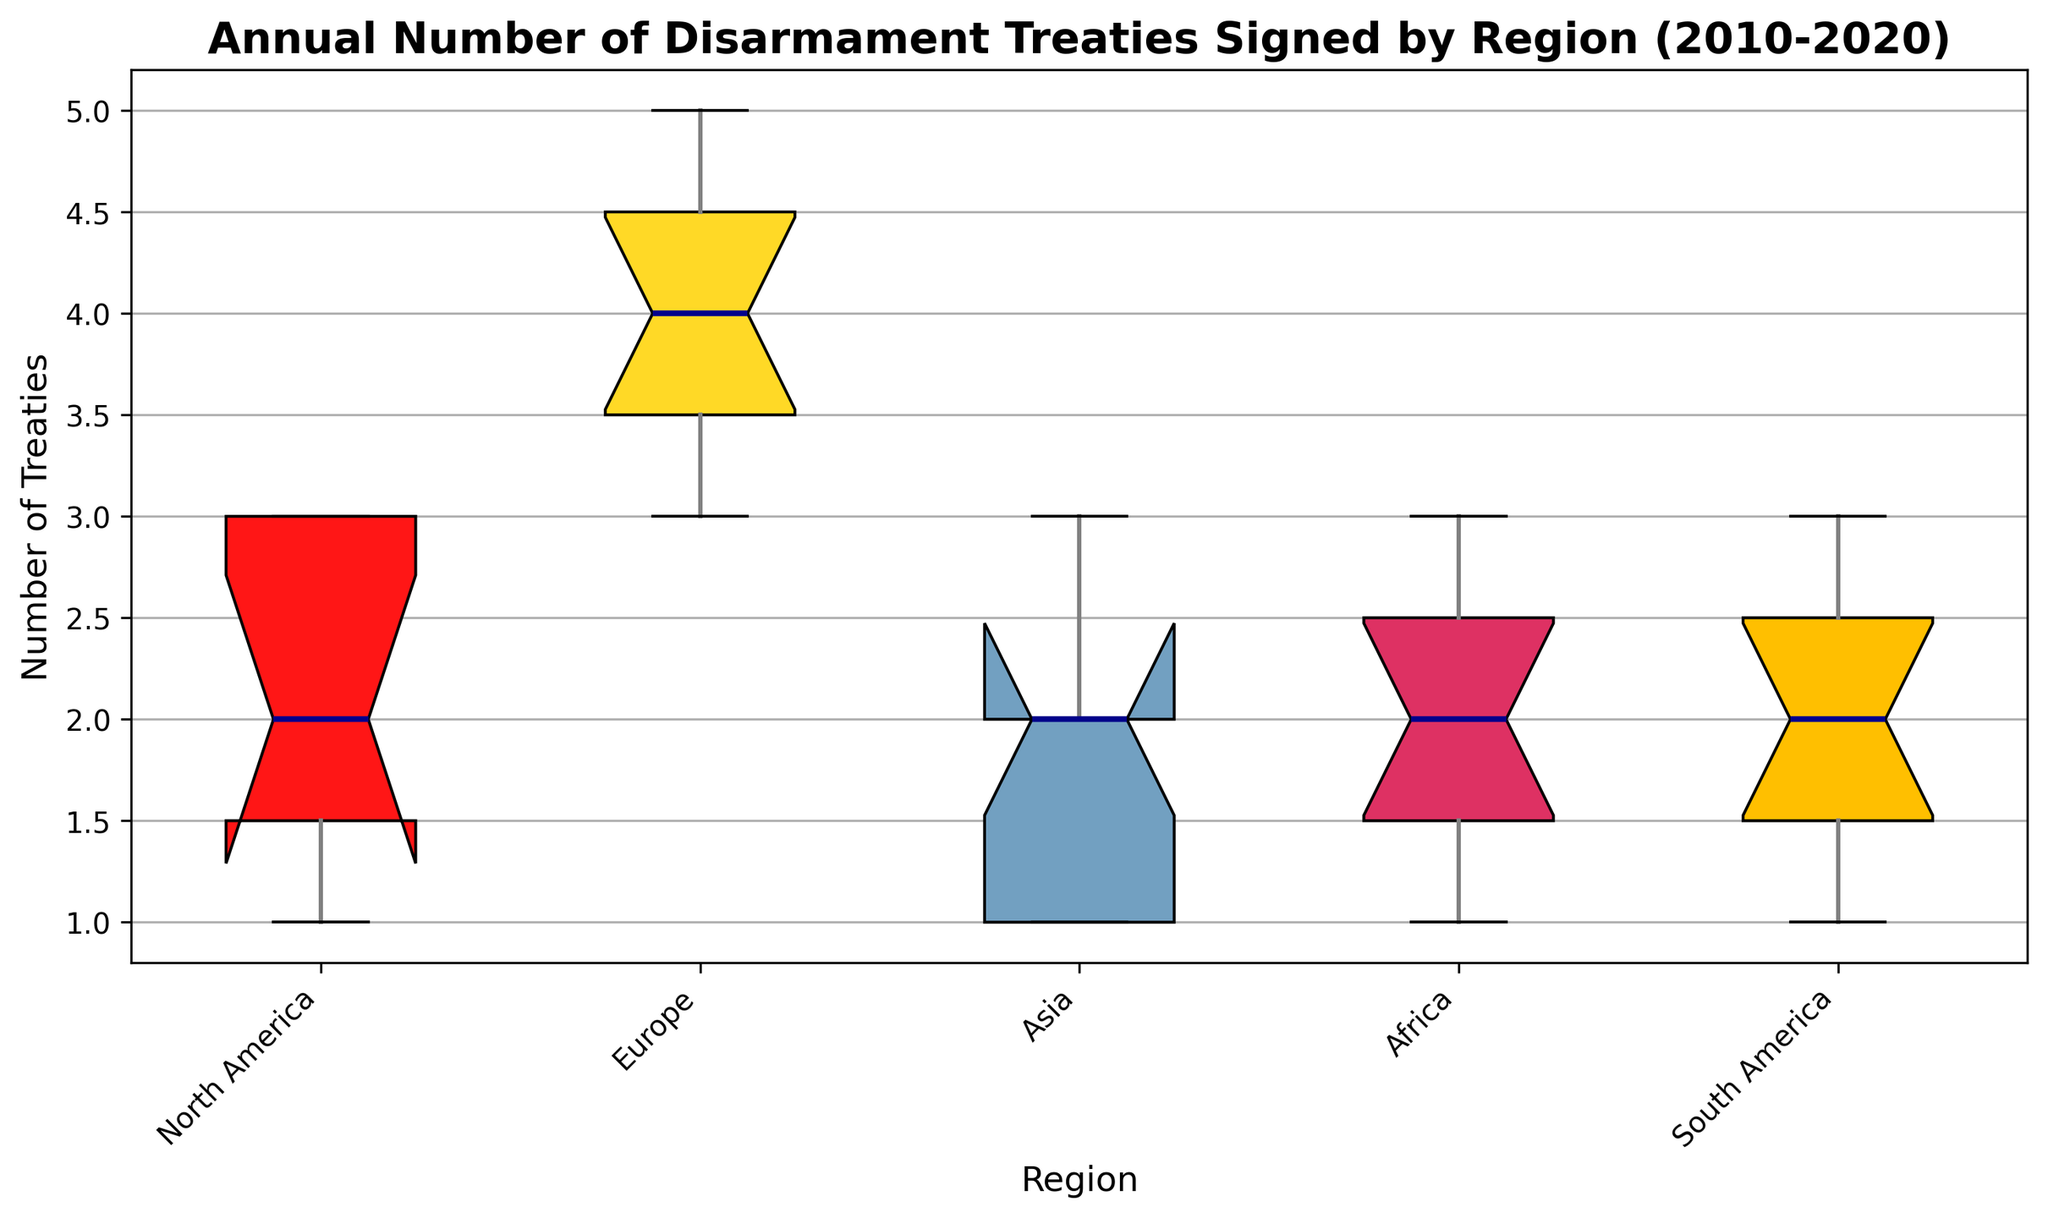Which region has the highest median number of treaties signed annually? Visually inspect the median lines within each box: North America's box plot has a median around 2, Europe around 4, Asia around 2, Africa around 2, and South America around 2. The highest median is Europe.
Answer: Europe Which region shows the most variability in the number of treaties signed annually? To determine this, look for the widest interquartile range (IQR) or the longest whiskers. Europe shows the widest IQR and longest whiskers, indicating the most variability.
Answer: Europe Are there any regions where the number of treaties signed annually remained constant across the years? If the box plot for a region is very narrow with no outliers, it suggests low variability and possibly a constant number. All regions show some variability; hence, none remained constant.
Answer: No Between North America and Asia, which region has a higher maximum number of treaties signed in a year? Compare the top whisker endpoints of North America and Asia. North America's top whisker ends at 3, and Asia's top whisker also ends at 3. Both have the same maximum number.
Answer: Equal Is there any region that has outliers? Outliers are usually depicted as individual points outside the whiskers. None of the box plots has individual points outside the whiskers, indicating no outliers.
Answer: No How does the median number of treaties signed in South America compare to that in North America? Visually compare the median lines of South America and North America. Both have a median around 2, indicating they are equal.
Answer: Equal Which region shows the least variability in the number of treaties signed annually? Look for the narrowest IQR or shortest whiskers. North America has the narrowest IQR and shortest whiskers, indicating the least variability.
Answer: North America Rank the regions from highest to lowest based on the median number of treaties signed annually. Visually inspect the median lines of each box plot: Europe (4) > North America (2) = Asia (2) = Africa (2) = South America (2). Europe is the highest, followed by the others equally.
Answer: Europe, North America = Asia = Africa = South America Do any regions have the same median number of treaties signed annually? If yes, which ones? By comparing the median lines, North America, Asia, Africa, and South America each have a median of approximately 2.
Answer: North America, Asia, Africa, South America What is the range of the number of treaties signed annually in Africa? Identify the endpoints of the whiskers for Africa. The lower whisker ends at 1, and the upper whisker ends at 3. The range is the difference: 3 - 1 = 2.
Answer: 2 